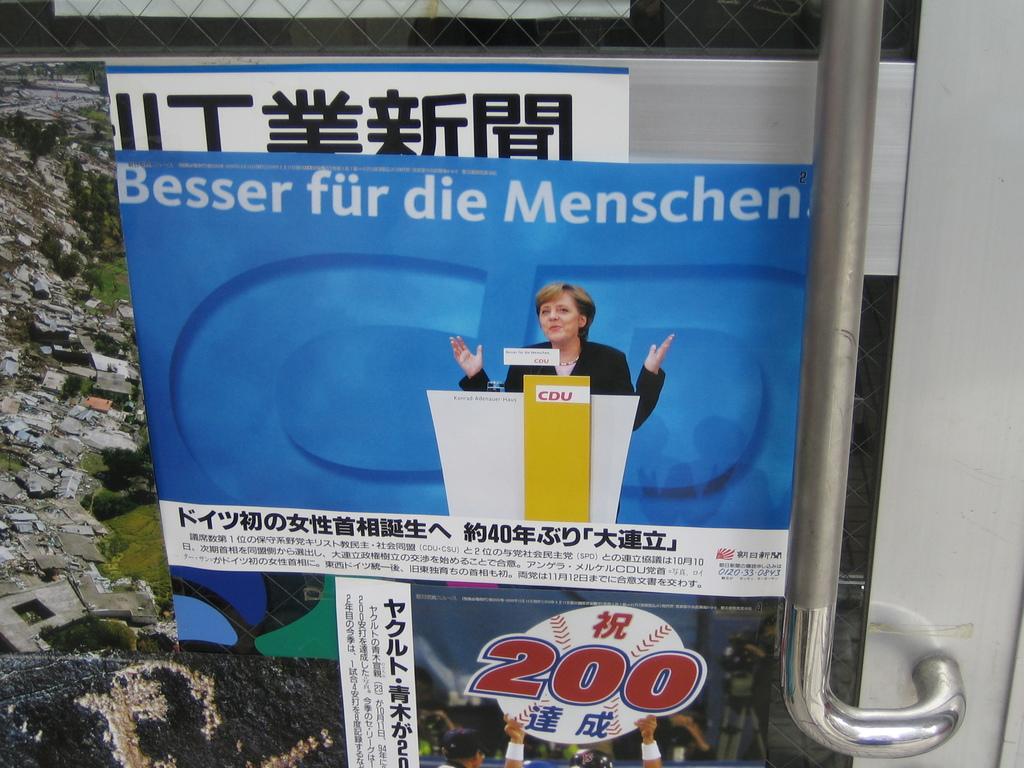What number is depicted on the baseball picture?
Provide a short and direct response. 200. 